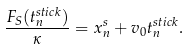Convert formula to latex. <formula><loc_0><loc_0><loc_500><loc_500>\frac { F _ { S } ( t _ { n } ^ { s t i c k } ) } { \kappa } = x _ { n } ^ { s } + v _ { 0 } t _ { n } ^ { s t i c k } .</formula> 